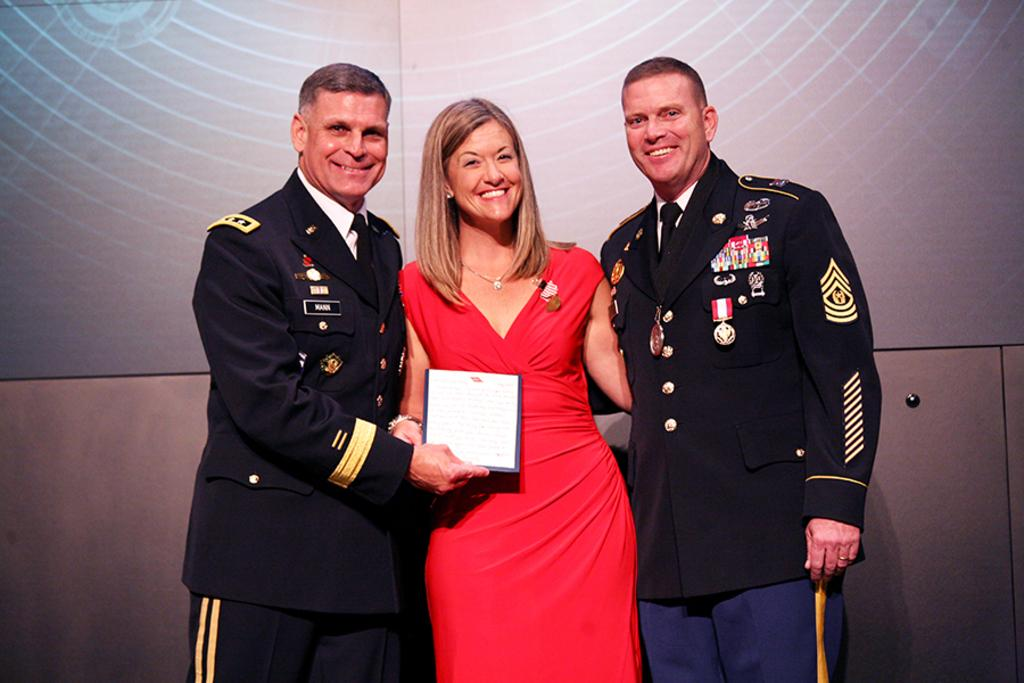How many people are in the image? There are three persons standing in the image. What is the person in front wearing? The person in front is wearing a red dress. What is the person in front holding? The person in front is holding a frame. What can be seen in the background of the image? There is a screen visible in the background of the image. What type of loaf is the girl smashing in the image? There is no girl or loaf present in the image. 